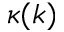<formula> <loc_0><loc_0><loc_500><loc_500>\kappa ( k )</formula> 